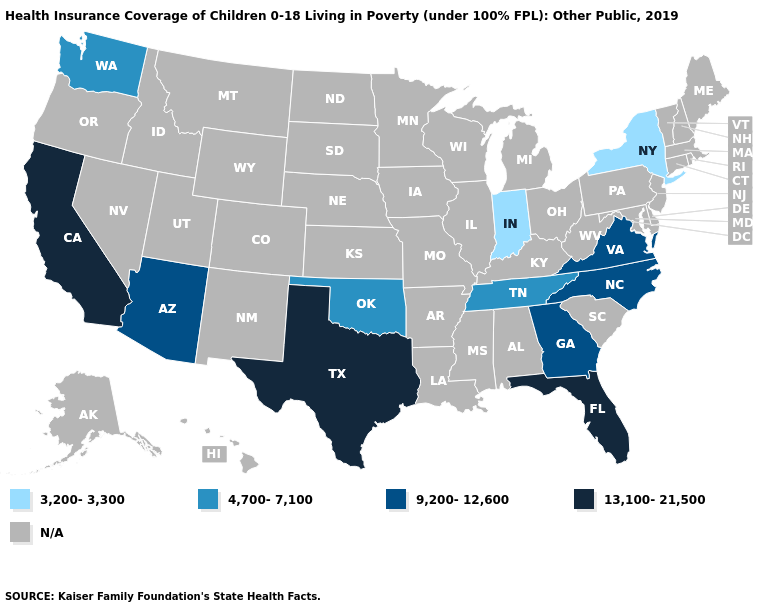What is the value of New York?
Give a very brief answer. 3,200-3,300. What is the lowest value in the West?
Quick response, please. 4,700-7,100. Name the states that have a value in the range 3,200-3,300?
Concise answer only. Indiana, New York. Which states have the lowest value in the USA?
Write a very short answer. Indiana, New York. What is the lowest value in the USA?
Quick response, please. 3,200-3,300. Name the states that have a value in the range 3,200-3,300?
Write a very short answer. Indiana, New York. What is the lowest value in the MidWest?
Write a very short answer. 3,200-3,300. Name the states that have a value in the range 3,200-3,300?
Concise answer only. Indiana, New York. Which states have the lowest value in the USA?
Give a very brief answer. Indiana, New York. What is the highest value in the Northeast ?
Write a very short answer. 3,200-3,300. What is the lowest value in the MidWest?
Concise answer only. 3,200-3,300. Name the states that have a value in the range 4,700-7,100?
Concise answer only. Oklahoma, Tennessee, Washington. 